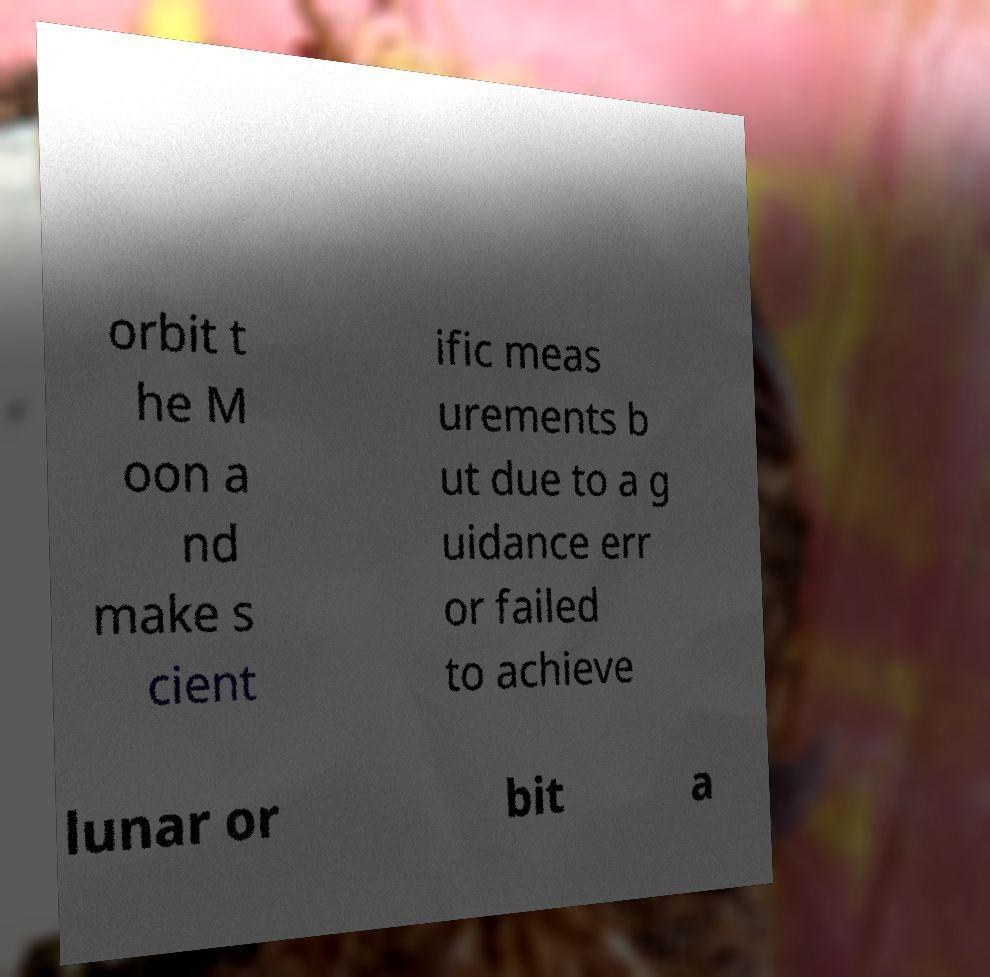For documentation purposes, I need the text within this image transcribed. Could you provide that? orbit t he M oon a nd make s cient ific meas urements b ut due to a g uidance err or failed to achieve lunar or bit a 